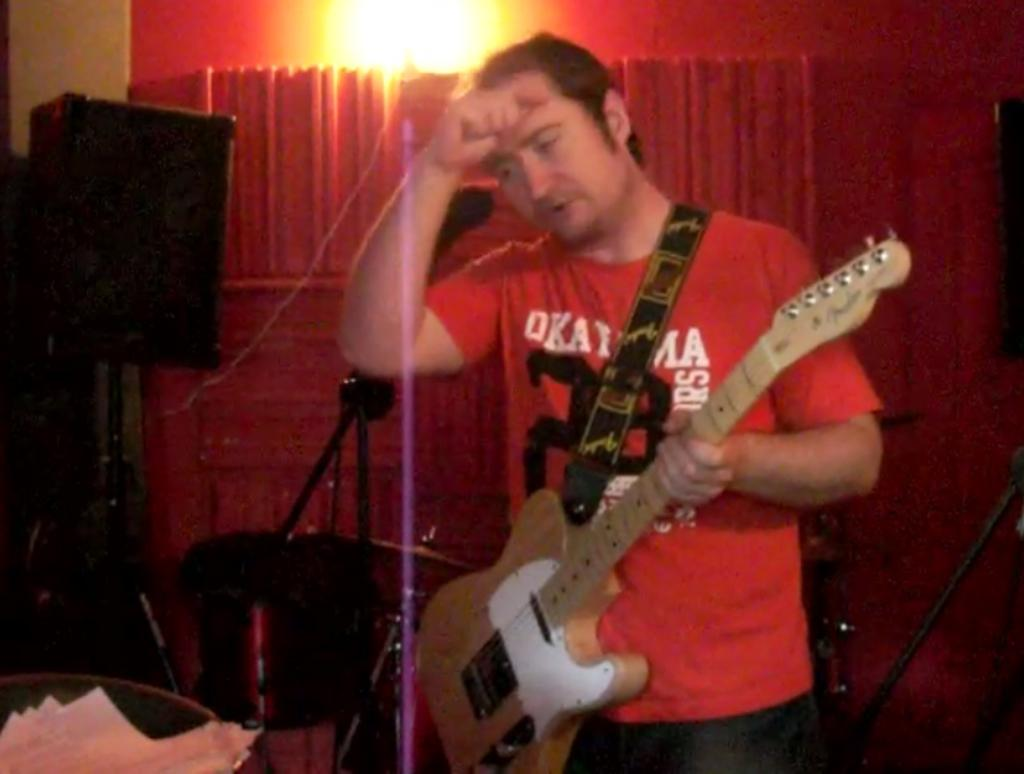What is the man in the image doing? The man is playing a guitar. Where is the man located in the image? The man is on a stage. What is the object behind the man? There is a sound box behind the man. How is the man being illuminated in the image? Light is focused on the man. What type of carpenter is the man in the image? The image does not indicate that the man is a carpenter; he is playing a guitar on a stage. Does the existence of the man in the image prove the existence of an alternate universe? The image does not provide any information about alternate universes; it simply shows a man playing a guitar on a stage. 